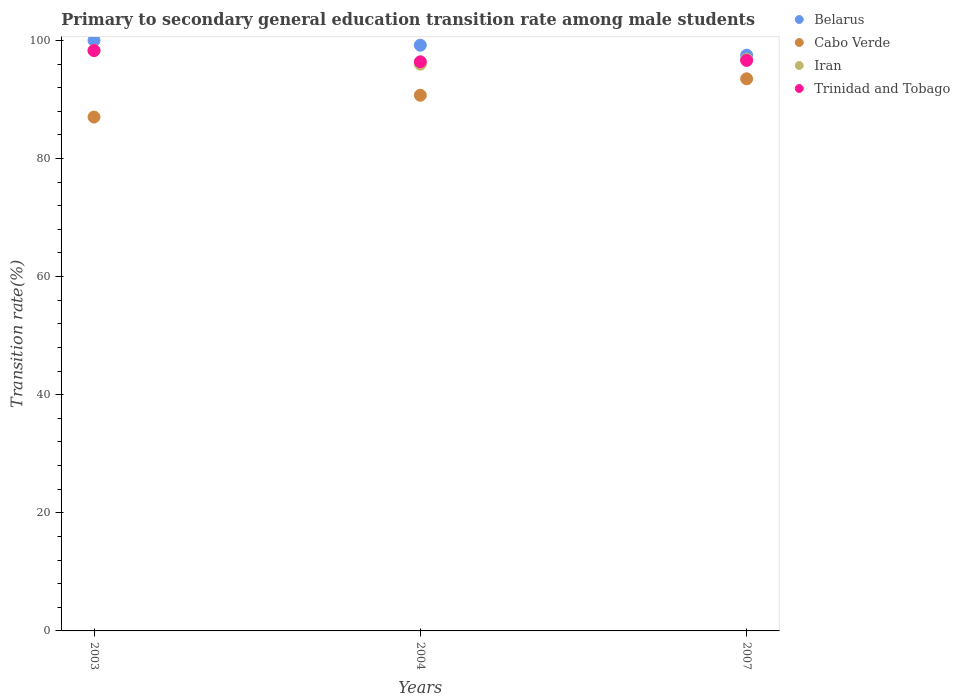Is the number of dotlines equal to the number of legend labels?
Ensure brevity in your answer.  Yes. What is the transition rate in Belarus in 2004?
Provide a succinct answer. 99.19. Across all years, what is the maximum transition rate in Iran?
Provide a succinct answer. 98.31. Across all years, what is the minimum transition rate in Trinidad and Tobago?
Provide a short and direct response. 96.38. In which year was the transition rate in Trinidad and Tobago maximum?
Your answer should be compact. 2003. What is the total transition rate in Belarus in the graph?
Your answer should be very brief. 296.68. What is the difference between the transition rate in Trinidad and Tobago in 2003 and that in 2007?
Your answer should be compact. 1.67. What is the difference between the transition rate in Belarus in 2004 and the transition rate in Cabo Verde in 2007?
Offer a very short reply. 5.69. What is the average transition rate in Belarus per year?
Your answer should be very brief. 98.89. In the year 2004, what is the difference between the transition rate in Cabo Verde and transition rate in Belarus?
Provide a short and direct response. -8.47. What is the ratio of the transition rate in Trinidad and Tobago in 2004 to that in 2007?
Your response must be concise. 1. What is the difference between the highest and the second highest transition rate in Belarus?
Your answer should be compact. 0.81. What is the difference between the highest and the lowest transition rate in Trinidad and Tobago?
Provide a succinct answer. 1.9. Is it the case that in every year, the sum of the transition rate in Iran and transition rate in Trinidad and Tobago  is greater than the transition rate in Belarus?
Make the answer very short. Yes. Does the transition rate in Belarus monotonically increase over the years?
Provide a short and direct response. No. Is the transition rate in Iran strictly less than the transition rate in Trinidad and Tobago over the years?
Your response must be concise. No. Are the values on the major ticks of Y-axis written in scientific E-notation?
Give a very brief answer. No. Does the graph contain grids?
Offer a very short reply. No. Where does the legend appear in the graph?
Give a very brief answer. Top right. How many legend labels are there?
Your answer should be compact. 4. How are the legend labels stacked?
Provide a succinct answer. Vertical. What is the title of the graph?
Provide a succinct answer. Primary to secondary general education transition rate among male students. What is the label or title of the Y-axis?
Your answer should be very brief. Transition rate(%). What is the Transition rate(%) in Cabo Verde in 2003?
Give a very brief answer. 87.02. What is the Transition rate(%) of Iran in 2003?
Offer a very short reply. 98.31. What is the Transition rate(%) of Trinidad and Tobago in 2003?
Offer a terse response. 98.28. What is the Transition rate(%) of Belarus in 2004?
Keep it short and to the point. 99.19. What is the Transition rate(%) in Cabo Verde in 2004?
Provide a short and direct response. 90.71. What is the Transition rate(%) of Iran in 2004?
Give a very brief answer. 95.97. What is the Transition rate(%) of Trinidad and Tobago in 2004?
Provide a succinct answer. 96.38. What is the Transition rate(%) in Belarus in 2007?
Ensure brevity in your answer.  97.49. What is the Transition rate(%) of Cabo Verde in 2007?
Your answer should be compact. 93.5. What is the Transition rate(%) in Iran in 2007?
Offer a terse response. 96.8. What is the Transition rate(%) in Trinidad and Tobago in 2007?
Keep it short and to the point. 96.61. Across all years, what is the maximum Transition rate(%) of Belarus?
Offer a terse response. 100. Across all years, what is the maximum Transition rate(%) of Cabo Verde?
Ensure brevity in your answer.  93.5. Across all years, what is the maximum Transition rate(%) of Iran?
Your answer should be compact. 98.31. Across all years, what is the maximum Transition rate(%) of Trinidad and Tobago?
Ensure brevity in your answer.  98.28. Across all years, what is the minimum Transition rate(%) of Belarus?
Make the answer very short. 97.49. Across all years, what is the minimum Transition rate(%) of Cabo Verde?
Your response must be concise. 87.02. Across all years, what is the minimum Transition rate(%) in Iran?
Your answer should be compact. 95.97. Across all years, what is the minimum Transition rate(%) in Trinidad and Tobago?
Offer a terse response. 96.38. What is the total Transition rate(%) of Belarus in the graph?
Provide a succinct answer. 296.68. What is the total Transition rate(%) in Cabo Verde in the graph?
Offer a terse response. 271.23. What is the total Transition rate(%) in Iran in the graph?
Provide a succinct answer. 291.08. What is the total Transition rate(%) of Trinidad and Tobago in the graph?
Your answer should be very brief. 291.27. What is the difference between the Transition rate(%) in Belarus in 2003 and that in 2004?
Keep it short and to the point. 0.81. What is the difference between the Transition rate(%) in Cabo Verde in 2003 and that in 2004?
Keep it short and to the point. -3.69. What is the difference between the Transition rate(%) of Iran in 2003 and that in 2004?
Give a very brief answer. 2.33. What is the difference between the Transition rate(%) in Trinidad and Tobago in 2003 and that in 2004?
Your answer should be compact. 1.9. What is the difference between the Transition rate(%) in Belarus in 2003 and that in 2007?
Give a very brief answer. 2.51. What is the difference between the Transition rate(%) of Cabo Verde in 2003 and that in 2007?
Keep it short and to the point. -6.47. What is the difference between the Transition rate(%) of Iran in 2003 and that in 2007?
Your answer should be very brief. 1.51. What is the difference between the Transition rate(%) in Trinidad and Tobago in 2003 and that in 2007?
Offer a very short reply. 1.67. What is the difference between the Transition rate(%) of Belarus in 2004 and that in 2007?
Your response must be concise. 1.69. What is the difference between the Transition rate(%) in Cabo Verde in 2004 and that in 2007?
Provide a succinct answer. -2.79. What is the difference between the Transition rate(%) in Iran in 2004 and that in 2007?
Give a very brief answer. -0.82. What is the difference between the Transition rate(%) of Trinidad and Tobago in 2004 and that in 2007?
Make the answer very short. -0.23. What is the difference between the Transition rate(%) in Belarus in 2003 and the Transition rate(%) in Cabo Verde in 2004?
Your answer should be very brief. 9.29. What is the difference between the Transition rate(%) of Belarus in 2003 and the Transition rate(%) of Iran in 2004?
Your answer should be very brief. 4.03. What is the difference between the Transition rate(%) of Belarus in 2003 and the Transition rate(%) of Trinidad and Tobago in 2004?
Offer a terse response. 3.62. What is the difference between the Transition rate(%) in Cabo Verde in 2003 and the Transition rate(%) in Iran in 2004?
Your answer should be compact. -8.95. What is the difference between the Transition rate(%) of Cabo Verde in 2003 and the Transition rate(%) of Trinidad and Tobago in 2004?
Provide a short and direct response. -9.36. What is the difference between the Transition rate(%) of Iran in 2003 and the Transition rate(%) of Trinidad and Tobago in 2004?
Give a very brief answer. 1.93. What is the difference between the Transition rate(%) of Belarus in 2003 and the Transition rate(%) of Cabo Verde in 2007?
Keep it short and to the point. 6.5. What is the difference between the Transition rate(%) of Belarus in 2003 and the Transition rate(%) of Iran in 2007?
Offer a very short reply. 3.2. What is the difference between the Transition rate(%) of Belarus in 2003 and the Transition rate(%) of Trinidad and Tobago in 2007?
Give a very brief answer. 3.39. What is the difference between the Transition rate(%) in Cabo Verde in 2003 and the Transition rate(%) in Iran in 2007?
Provide a short and direct response. -9.77. What is the difference between the Transition rate(%) of Cabo Verde in 2003 and the Transition rate(%) of Trinidad and Tobago in 2007?
Your answer should be very brief. -9.59. What is the difference between the Transition rate(%) of Iran in 2003 and the Transition rate(%) of Trinidad and Tobago in 2007?
Your response must be concise. 1.7. What is the difference between the Transition rate(%) in Belarus in 2004 and the Transition rate(%) in Cabo Verde in 2007?
Provide a succinct answer. 5.69. What is the difference between the Transition rate(%) of Belarus in 2004 and the Transition rate(%) of Iran in 2007?
Give a very brief answer. 2.39. What is the difference between the Transition rate(%) in Belarus in 2004 and the Transition rate(%) in Trinidad and Tobago in 2007?
Your answer should be very brief. 2.58. What is the difference between the Transition rate(%) of Cabo Verde in 2004 and the Transition rate(%) of Iran in 2007?
Your response must be concise. -6.08. What is the difference between the Transition rate(%) in Cabo Verde in 2004 and the Transition rate(%) in Trinidad and Tobago in 2007?
Your answer should be compact. -5.9. What is the difference between the Transition rate(%) of Iran in 2004 and the Transition rate(%) of Trinidad and Tobago in 2007?
Keep it short and to the point. -0.64. What is the average Transition rate(%) of Belarus per year?
Keep it short and to the point. 98.89. What is the average Transition rate(%) of Cabo Verde per year?
Your answer should be compact. 90.41. What is the average Transition rate(%) in Iran per year?
Keep it short and to the point. 97.03. What is the average Transition rate(%) of Trinidad and Tobago per year?
Keep it short and to the point. 97.09. In the year 2003, what is the difference between the Transition rate(%) in Belarus and Transition rate(%) in Cabo Verde?
Make the answer very short. 12.98. In the year 2003, what is the difference between the Transition rate(%) of Belarus and Transition rate(%) of Iran?
Your answer should be compact. 1.69. In the year 2003, what is the difference between the Transition rate(%) of Belarus and Transition rate(%) of Trinidad and Tobago?
Give a very brief answer. 1.72. In the year 2003, what is the difference between the Transition rate(%) of Cabo Verde and Transition rate(%) of Iran?
Give a very brief answer. -11.28. In the year 2003, what is the difference between the Transition rate(%) in Cabo Verde and Transition rate(%) in Trinidad and Tobago?
Your answer should be very brief. -11.26. In the year 2003, what is the difference between the Transition rate(%) of Iran and Transition rate(%) of Trinidad and Tobago?
Keep it short and to the point. 0.03. In the year 2004, what is the difference between the Transition rate(%) in Belarus and Transition rate(%) in Cabo Verde?
Ensure brevity in your answer.  8.47. In the year 2004, what is the difference between the Transition rate(%) in Belarus and Transition rate(%) in Iran?
Offer a terse response. 3.21. In the year 2004, what is the difference between the Transition rate(%) in Belarus and Transition rate(%) in Trinidad and Tobago?
Provide a succinct answer. 2.81. In the year 2004, what is the difference between the Transition rate(%) in Cabo Verde and Transition rate(%) in Iran?
Your response must be concise. -5.26. In the year 2004, what is the difference between the Transition rate(%) of Cabo Verde and Transition rate(%) of Trinidad and Tobago?
Make the answer very short. -5.67. In the year 2004, what is the difference between the Transition rate(%) in Iran and Transition rate(%) in Trinidad and Tobago?
Offer a very short reply. -0.4. In the year 2007, what is the difference between the Transition rate(%) of Belarus and Transition rate(%) of Cabo Verde?
Keep it short and to the point. 4. In the year 2007, what is the difference between the Transition rate(%) of Belarus and Transition rate(%) of Iran?
Provide a short and direct response. 0.7. In the year 2007, what is the difference between the Transition rate(%) in Belarus and Transition rate(%) in Trinidad and Tobago?
Ensure brevity in your answer.  0.89. In the year 2007, what is the difference between the Transition rate(%) in Cabo Verde and Transition rate(%) in Iran?
Your response must be concise. -3.3. In the year 2007, what is the difference between the Transition rate(%) in Cabo Verde and Transition rate(%) in Trinidad and Tobago?
Your response must be concise. -3.11. In the year 2007, what is the difference between the Transition rate(%) in Iran and Transition rate(%) in Trinidad and Tobago?
Offer a terse response. 0.19. What is the ratio of the Transition rate(%) of Belarus in 2003 to that in 2004?
Provide a succinct answer. 1.01. What is the ratio of the Transition rate(%) in Cabo Verde in 2003 to that in 2004?
Offer a terse response. 0.96. What is the ratio of the Transition rate(%) in Iran in 2003 to that in 2004?
Offer a terse response. 1.02. What is the ratio of the Transition rate(%) in Trinidad and Tobago in 2003 to that in 2004?
Make the answer very short. 1.02. What is the ratio of the Transition rate(%) in Belarus in 2003 to that in 2007?
Make the answer very short. 1.03. What is the ratio of the Transition rate(%) of Cabo Verde in 2003 to that in 2007?
Offer a terse response. 0.93. What is the ratio of the Transition rate(%) of Iran in 2003 to that in 2007?
Make the answer very short. 1.02. What is the ratio of the Transition rate(%) in Trinidad and Tobago in 2003 to that in 2007?
Offer a terse response. 1.02. What is the ratio of the Transition rate(%) in Belarus in 2004 to that in 2007?
Give a very brief answer. 1.02. What is the ratio of the Transition rate(%) of Cabo Verde in 2004 to that in 2007?
Your answer should be compact. 0.97. What is the ratio of the Transition rate(%) in Iran in 2004 to that in 2007?
Offer a terse response. 0.99. What is the difference between the highest and the second highest Transition rate(%) in Belarus?
Offer a very short reply. 0.81. What is the difference between the highest and the second highest Transition rate(%) of Cabo Verde?
Provide a short and direct response. 2.79. What is the difference between the highest and the second highest Transition rate(%) of Iran?
Your answer should be very brief. 1.51. What is the difference between the highest and the second highest Transition rate(%) in Trinidad and Tobago?
Offer a terse response. 1.67. What is the difference between the highest and the lowest Transition rate(%) of Belarus?
Make the answer very short. 2.51. What is the difference between the highest and the lowest Transition rate(%) in Cabo Verde?
Provide a succinct answer. 6.47. What is the difference between the highest and the lowest Transition rate(%) of Iran?
Keep it short and to the point. 2.33. What is the difference between the highest and the lowest Transition rate(%) in Trinidad and Tobago?
Ensure brevity in your answer.  1.9. 